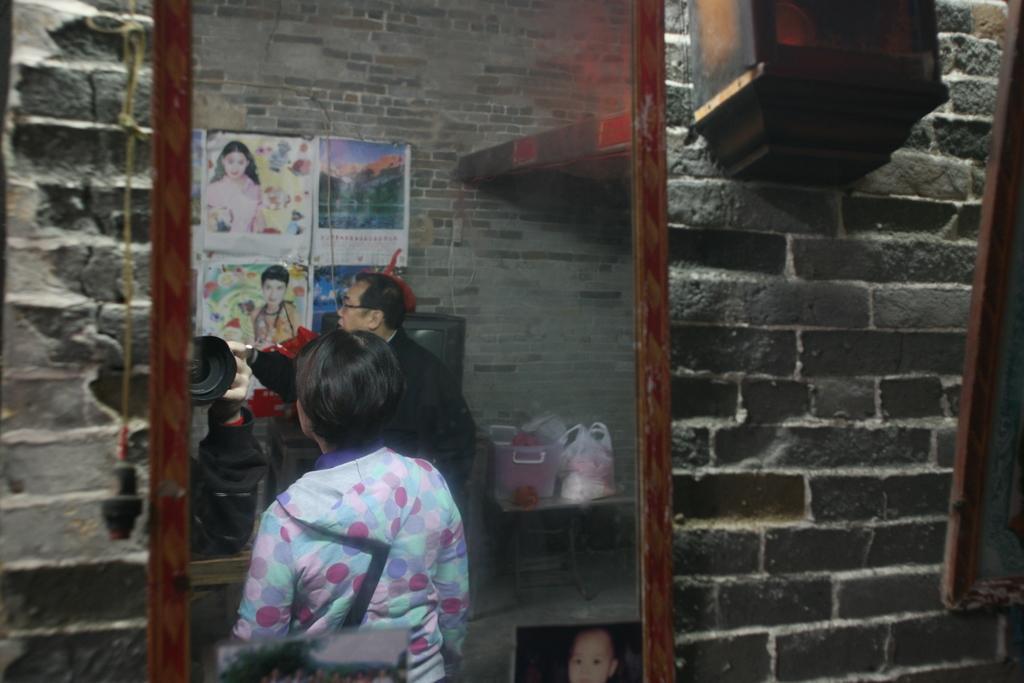Can you describe this image briefly? In this image I see the wall and over here I see 2 persons and I see few posts on the wall and I see few things over here and I see that this is a mirror and I see a picture of a child over here and I see a thing over here which is of black in color. 